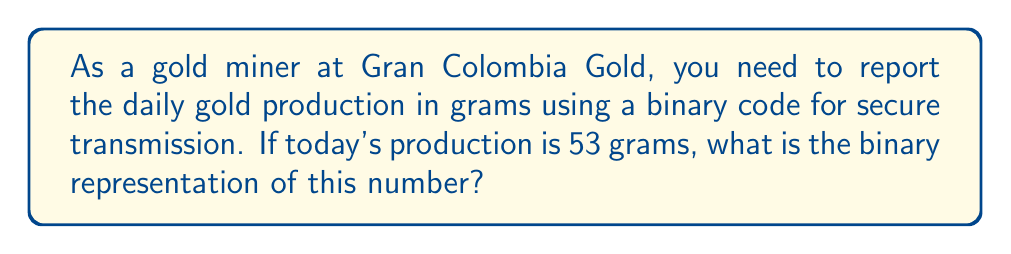Can you solve this math problem? To convert the decimal number 53 to binary, we need to follow these steps:

1) Divide the number by 2 repeatedly until the quotient becomes 0.
2) Write down the remainders in reverse order.

Let's perform the division:

$$ 53 \div 2 = 26 \text{ remainder } 1 $$
$$ 26 \div 2 = 13 \text{ remainder } 0 $$
$$ 13 \div 2 = 6 \text{ remainder } 1 $$
$$ 6 \div 2 = 3 \text{ remainder } 0 $$
$$ 3 \div 2 = 1 \text{ remainder } 1 $$
$$ 1 \div 2 = 0 \text{ remainder } 1 $$

Now, reading the remainders from bottom to top, we get:

$$ 53_{10} = 110101_2 $$

This can be verified by expanding the binary number:

$$ 1\cdot2^5 + 1\cdot2^4 + 0\cdot2^3 + 1\cdot2^2 + 0\cdot2^1 + 1\cdot2^0 $$
$$ = 32 + 16 + 0 + 4 + 0 + 1 = 53 $$

Therefore, 53 grams of gold production would be represented as 110101 in binary.
Answer: $110101_2$ 